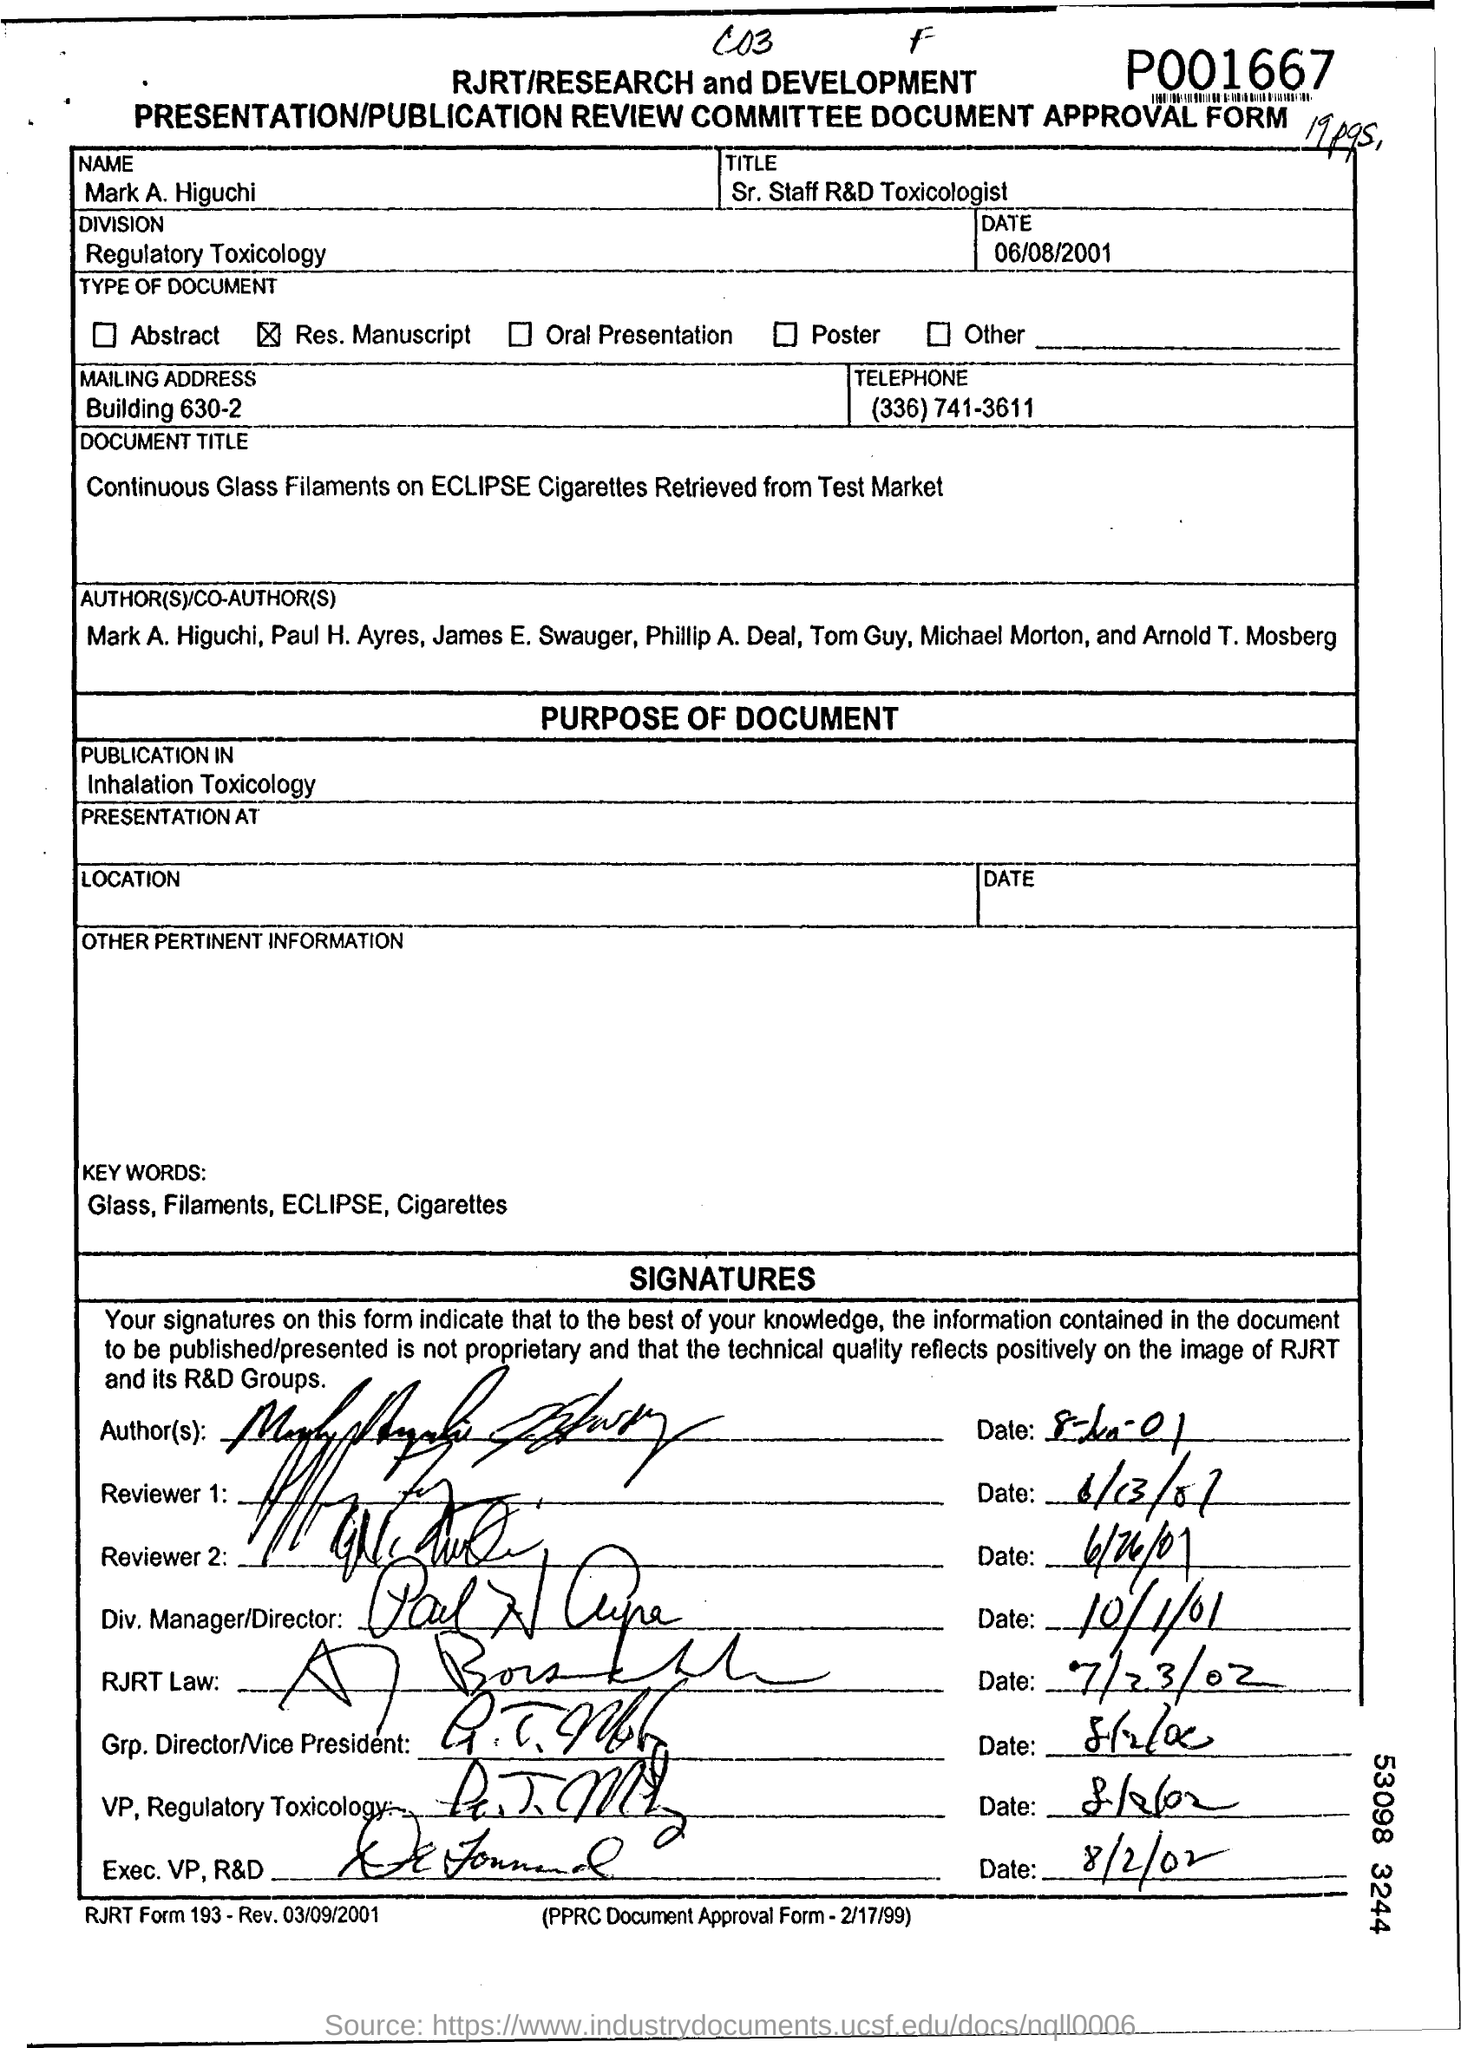What is the title of Mark A. Higuchi?
Give a very brief answer. Sr. Staff R&D Toxicologist. To which division does mark a. higuchi belongs?
Offer a terse response. Regulatory toxicology. What is the mailing  address of mark a. higuchi ?
Ensure brevity in your answer.  Building 630-2. 